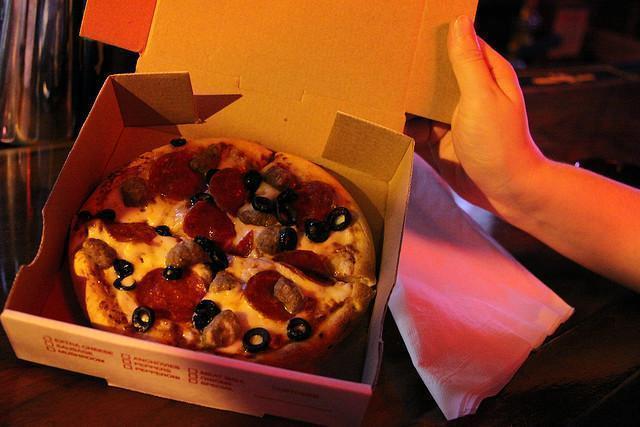What type person would enjoy this pizza?
From the following set of four choices, select the accurate answer to respond to the question.
Options: No one, vegan, omnivore, vegetarian. Omnivore. 